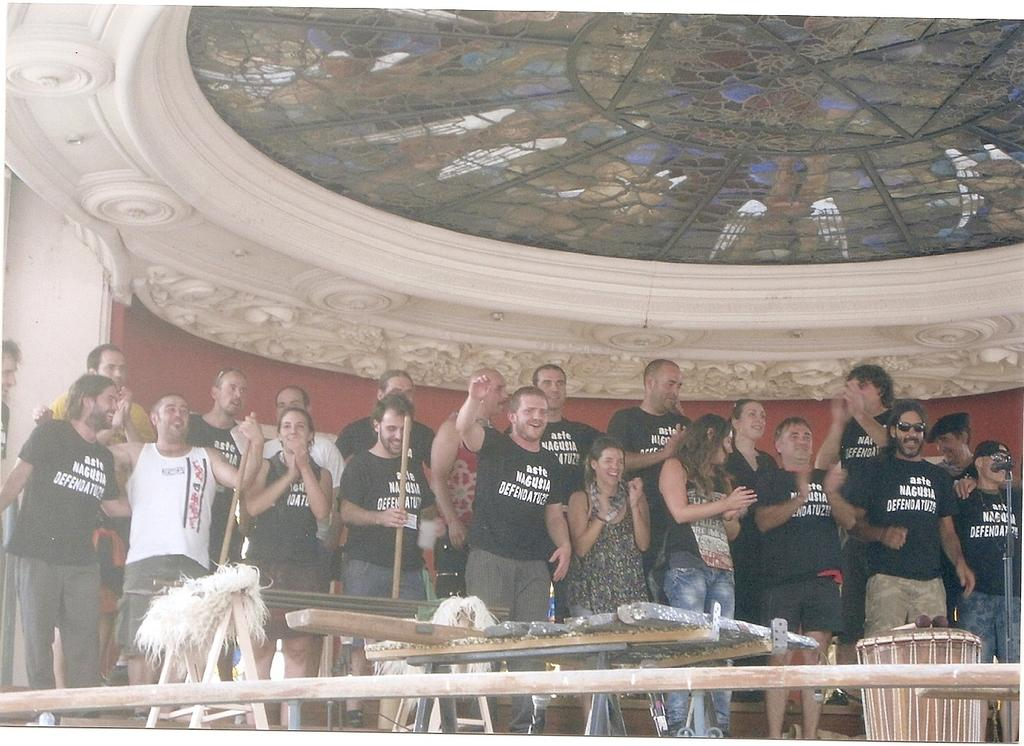What is happening in the image? There are people standing in the image. What can be seen in front of the people? There are objects in front of the people. What part of the room can be seen at the top of the image? The ceiling is visible at the top of the image. What type of ice is being used by the people in the image? There is no ice present in the image, and the people are not using any ice. What is the partner of the person standing on the left doing in the image? There is no partner visible in the image, and we cannot determine what they might be doing. 